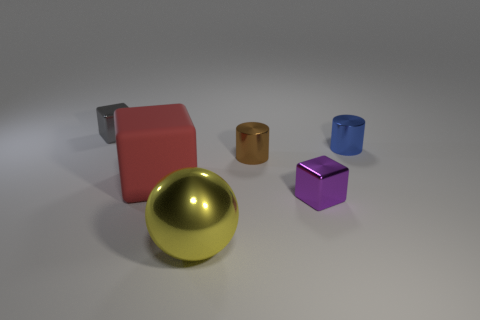Are there any other things that are the same shape as the yellow thing?
Offer a terse response. No. What is the size of the matte thing?
Offer a very short reply. Large. There is a metallic thing in front of the purple metallic cube; does it have the same size as the metallic thing left of the shiny ball?
Give a very brief answer. No. There is another thing that is the same shape as the small blue metallic thing; what size is it?
Your response must be concise. Small. There is a gray cube; does it have the same size as the red rubber thing that is on the left side of the large yellow ball?
Your response must be concise. No. Is there a metallic object that is on the right side of the small metallic thing left of the small brown object?
Provide a succinct answer. Yes. There is a small object that is to the right of the tiny purple metallic block; what shape is it?
Your response must be concise. Cylinder. The small shiny block that is behind the cube on the right side of the big shiny thing is what color?
Give a very brief answer. Gray. Is the size of the brown cylinder the same as the yellow object?
Provide a succinct answer. No. There is a big red thing that is the same shape as the small purple object; what is it made of?
Ensure brevity in your answer.  Rubber. 